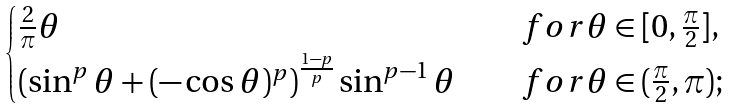Convert formula to latex. <formula><loc_0><loc_0><loc_500><loc_500>\begin{cases} \frac { 2 } { \pi } \theta & \quad f o r \theta \in [ 0 , \frac { \pi } { 2 } ] , \\ \left ( \sin ^ { p } \theta + ( - \cos \theta ) ^ { p } \right ) ^ { \frac { 1 - p } { p } } \sin ^ { p - 1 } \theta & \quad f o r \theta \in ( \frac { \pi } { 2 } , \pi ) ; \\ \end{cases}</formula> 